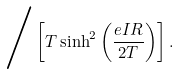Convert formula to latex. <formula><loc_0><loc_0><loc_500><loc_500>\Big / \left [ T \sinh ^ { 2 } \left ( \frac { e I R } { 2 T } \right ) \right ] .</formula> 